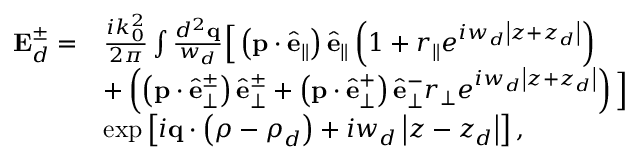Convert formula to latex. <formula><loc_0><loc_0><loc_500><loc_500>\begin{array} { r l } { E _ { d } ^ { \pm } = } & { \frac { i k _ { 0 } ^ { 2 } } { 2 \pi } \int \frac { d ^ { 2 } q } { w _ { d } } \left [ \left ( p \cdot \hat { e } _ { \| } \right ) \hat { e } _ { \| } \left ( 1 + r _ { \| } e ^ { i w _ { d } \left | z + z _ { d } \right | } \right ) } \\ & { + \left ( \left ( p \cdot \hat { e } _ { \perp } ^ { \pm } \right ) \hat { e } _ { \perp } ^ { \pm } + \left ( p \cdot \hat { e } _ { \perp } ^ { + } \right ) \hat { e } _ { \perp } ^ { - } r _ { \perp } e ^ { i w _ { d } \left | z + z _ { d } \right | } \right ) \right ] } \\ & { \exp \left [ i q \cdot \left ( \rho - \rho _ { d } \right ) + i w _ { d } \left | z - z _ { d } \right | \right ] , } \end{array}</formula> 